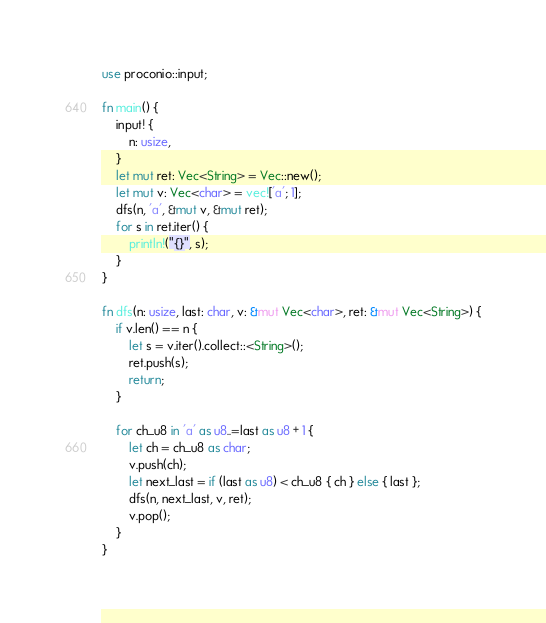<code> <loc_0><loc_0><loc_500><loc_500><_Rust_>use proconio::input;

fn main() {
    input! {
        n: usize,
    }
    let mut ret: Vec<String> = Vec::new();
    let mut v: Vec<char> = vec!['a'; 1];
    dfs(n, 'a', &mut v, &mut ret);
    for s in ret.iter() {
        println!("{}", s);
    }
}

fn dfs(n: usize, last: char, v: &mut Vec<char>, ret: &mut Vec<String>) {
    if v.len() == n {
        let s = v.iter().collect::<String>();
        ret.push(s);
        return;
    }

    for ch_u8 in 'a' as u8..=last as u8 + 1 {
        let ch = ch_u8 as char;
        v.push(ch);
        let next_last = if (last as u8) < ch_u8 { ch } else { last };
        dfs(n, next_last, v, ret);
        v.pop();
    }
}
</code> 